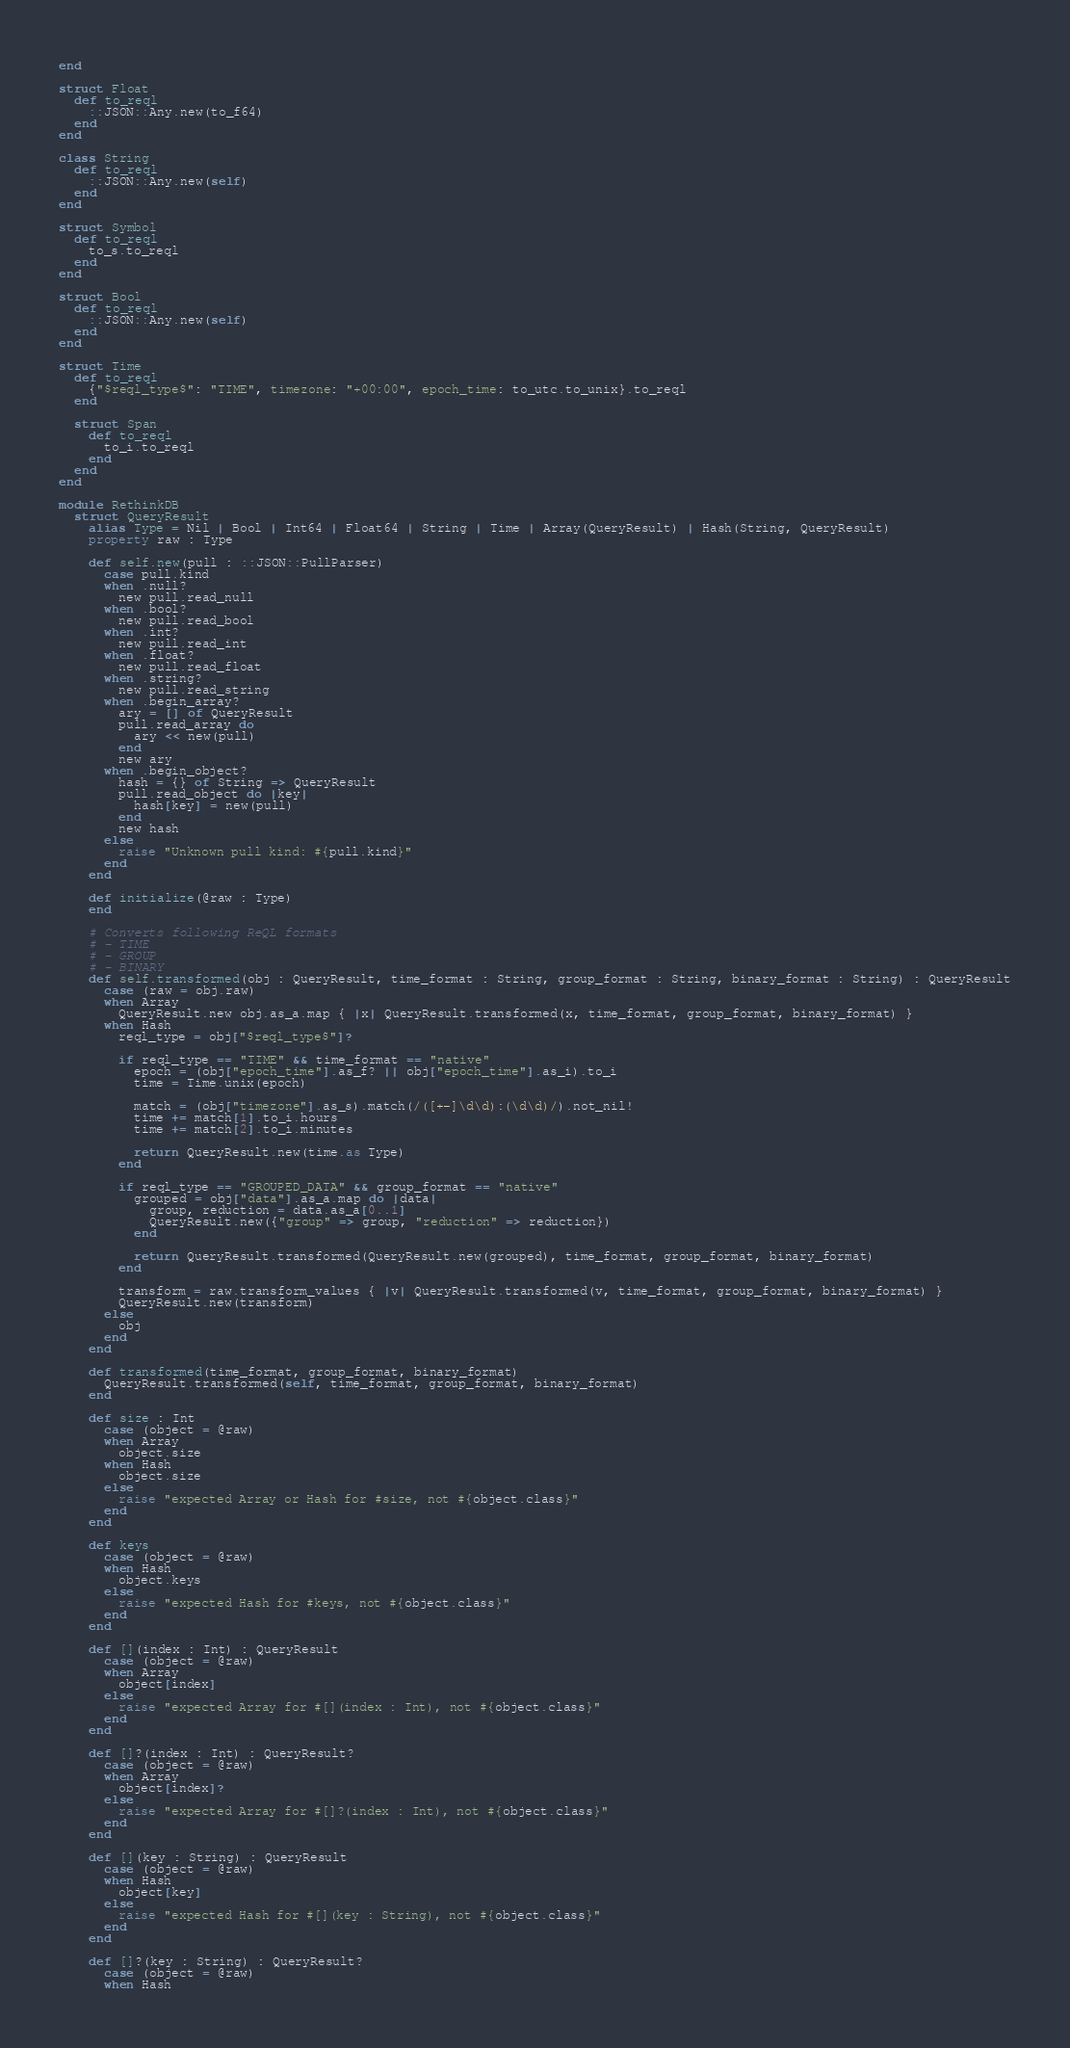Convert code to text. <code><loc_0><loc_0><loc_500><loc_500><_Crystal_>end

struct Float
  def to_reql
    ::JSON::Any.new(to_f64)
  end
end

class String
  def to_reql
    ::JSON::Any.new(self)
  end
end

struct Symbol
  def to_reql
    to_s.to_reql
  end
end

struct Bool
  def to_reql
    ::JSON::Any.new(self)
  end
end

struct Time
  def to_reql
    {"$reql_type$": "TIME", timezone: "+00:00", epoch_time: to_utc.to_unix}.to_reql
  end

  struct Span
    def to_reql
      to_i.to_reql
    end
  end
end

module RethinkDB
  struct QueryResult
    alias Type = Nil | Bool | Int64 | Float64 | String | Time | Array(QueryResult) | Hash(String, QueryResult)
    property raw : Type

    def self.new(pull : ::JSON::PullParser)
      case pull.kind
      when .null?
        new pull.read_null
      when .bool?
        new pull.read_bool
      when .int?
        new pull.read_int
      when .float?
        new pull.read_float
      when .string?
        new pull.read_string
      when .begin_array?
        ary = [] of QueryResult
        pull.read_array do
          ary << new(pull)
        end
        new ary
      when .begin_object?
        hash = {} of String => QueryResult
        pull.read_object do |key|
          hash[key] = new(pull)
        end
        new hash
      else
        raise "Unknown pull kind: #{pull.kind}"
      end
    end

    def initialize(@raw : Type)
    end

    # Converts following ReQL formats
    # - TIME
    # - GROUP
    # - BINARY
    def self.transformed(obj : QueryResult, time_format : String, group_format : String, binary_format : String) : QueryResult
      case (raw = obj.raw)
      when Array
        QueryResult.new obj.as_a.map { |x| QueryResult.transformed(x, time_format, group_format, binary_format) }
      when Hash
        reql_type = obj["$reql_type$"]?

        if reql_type == "TIME" && time_format == "native"
          epoch = (obj["epoch_time"].as_f? || obj["epoch_time"].as_i).to_i
          time = Time.unix(epoch)

          match = (obj["timezone"].as_s).match(/([+-]\d\d):(\d\d)/).not_nil!
          time += match[1].to_i.hours
          time += match[2].to_i.minutes

          return QueryResult.new(time.as Type)
        end

        if reql_type == "GROUPED_DATA" && group_format == "native"
          grouped = obj["data"].as_a.map do |data|
            group, reduction = data.as_a[0..1]
            QueryResult.new({"group" => group, "reduction" => reduction})
          end

          return QueryResult.transformed(QueryResult.new(grouped), time_format, group_format, binary_format)
        end

        transform = raw.transform_values { |v| QueryResult.transformed(v, time_format, group_format, binary_format) }
        QueryResult.new(transform)
      else
        obj
      end
    end

    def transformed(time_format, group_format, binary_format)
      QueryResult.transformed(self, time_format, group_format, binary_format)
    end

    def size : Int
      case (object = @raw)
      when Array
        object.size
      when Hash
        object.size
      else
        raise "expected Array or Hash for #size, not #{object.class}"
      end
    end

    def keys
      case (object = @raw)
      when Hash
        object.keys
      else
        raise "expected Hash for #keys, not #{object.class}"
      end
    end

    def [](index : Int) : QueryResult
      case (object = @raw)
      when Array
        object[index]
      else
        raise "expected Array for #[](index : Int), not #{object.class}"
      end
    end

    def []?(index : Int) : QueryResult?
      case (object = @raw)
      when Array
        object[index]?
      else
        raise "expected Array for #[]?(index : Int), not #{object.class}"
      end
    end

    def [](key : String) : QueryResult
      case (object = @raw)
      when Hash
        object[key]
      else
        raise "expected Hash for #[](key : String), not #{object.class}"
      end
    end

    def []?(key : String) : QueryResult?
      case (object = @raw)
      when Hash</code> 